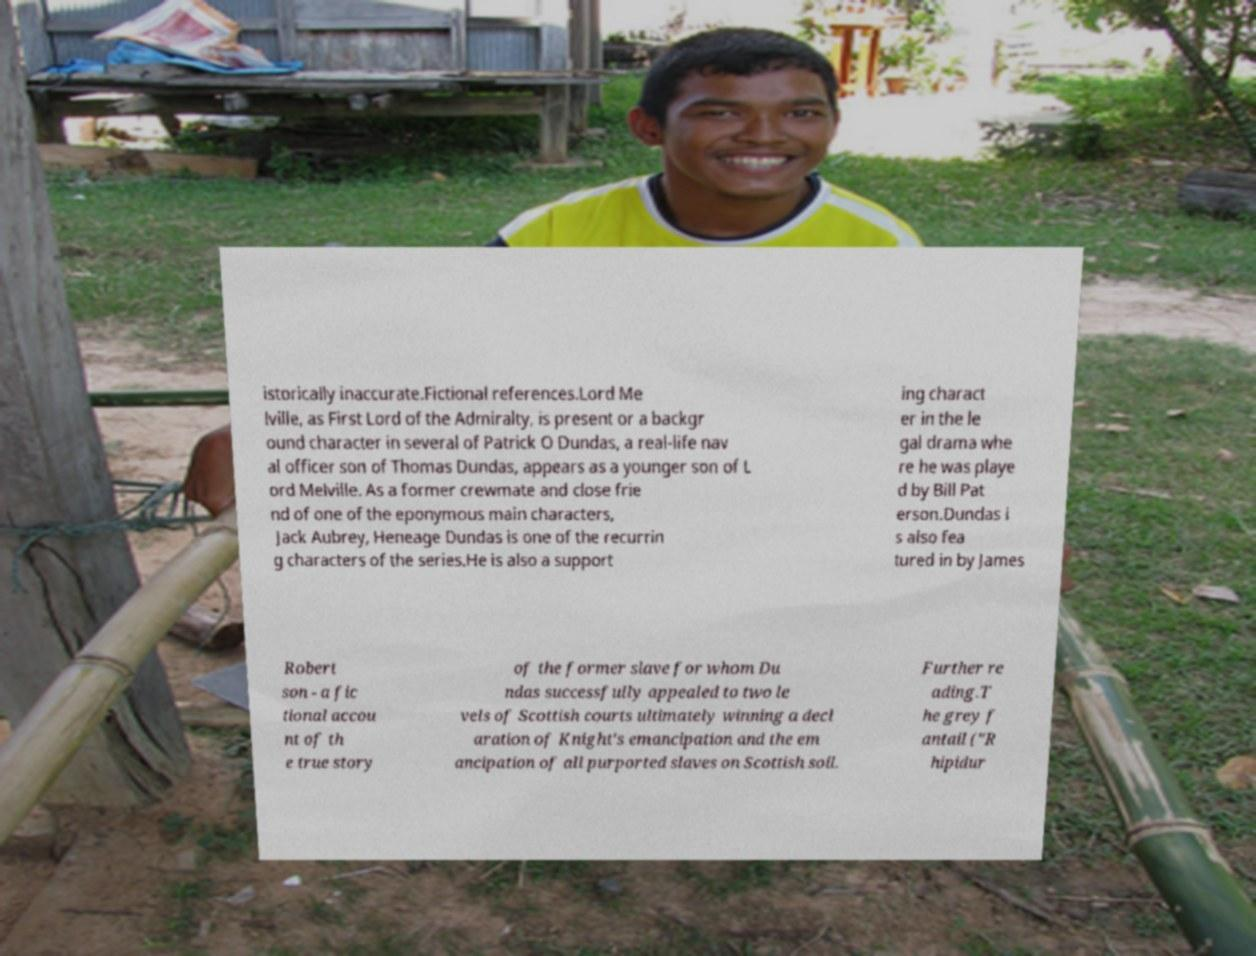Please read and relay the text visible in this image. What does it say? istorically inaccurate.Fictional references.Lord Me lville, as First Lord of the Admiralty, is present or a backgr ound character in several of Patrick O Dundas, a real-life nav al officer son of Thomas Dundas, appears as a younger son of L ord Melville. As a former crewmate and close frie nd of one of the eponymous main characters, Jack Aubrey, Heneage Dundas is one of the recurrin g characters of the series.He is also a support ing charact er in the le gal drama whe re he was playe d by Bill Pat erson.Dundas i s also fea tured in by James Robert son - a fic tional accou nt of th e true story of the former slave for whom Du ndas successfully appealed to two le vels of Scottish courts ultimately winning a decl aration of Knight's emancipation and the em ancipation of all purported slaves on Scottish soil. Further re ading.T he grey f antail ("R hipidur 